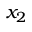<formula> <loc_0><loc_0><loc_500><loc_500>x _ { 2 }</formula> 